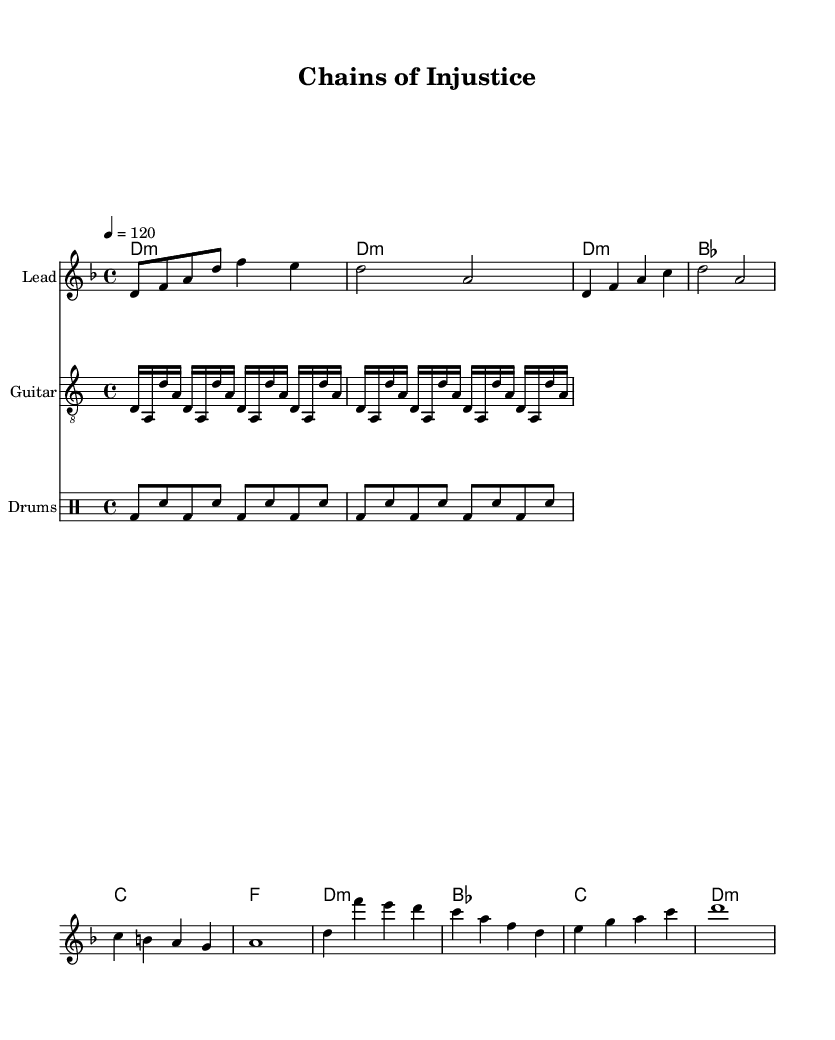What is the key signature of this music? The key signature is D minor, which includes one flat (B flat). This can be determined from the key signature indicated at the beginning of the sheet music and the tonalities present in the melody and harmonies.
Answer: D minor What is the time signature of this music? The time signature is 4/4, as indicated in the beginning of the score. This means there are four beats in each measure, and the quarter note gets one beat.
Answer: 4/4 What is the tempo marking for this music? The tempo marking is 120 beats per minute, shown directly in the score as "4 = 120". This indicates the speed at which the piece should be played.
Answer: 120 How many measures are in the chorus? The chorus consists of four measures, as shown by looking at the chorus section of the sheet music which includes four distinct lines of music.
Answer: Four What is the primary theme addressed in the lyrics? The primary theme of the lyrics addresses wrongful convictions and injustice within the legal system, as evident from lines discussing "chains of injustice" and "innocent lives".
Answer: Injustice How many different instrumental parts are present in this score? The score contains four different instrumental parts: the lead (melody), guitar, drums, and chord names. Each part is labeled and displayed in the score.
Answer: Four What is the significance of the guitar riff in this piece? The guitar riff provides an aggressive and rhythmic underpinning typical in metal music, which enhances the overall intensity of the piece and underscores the lyrical themes of struggle and injustice.
Answer: Aggressive intensity 